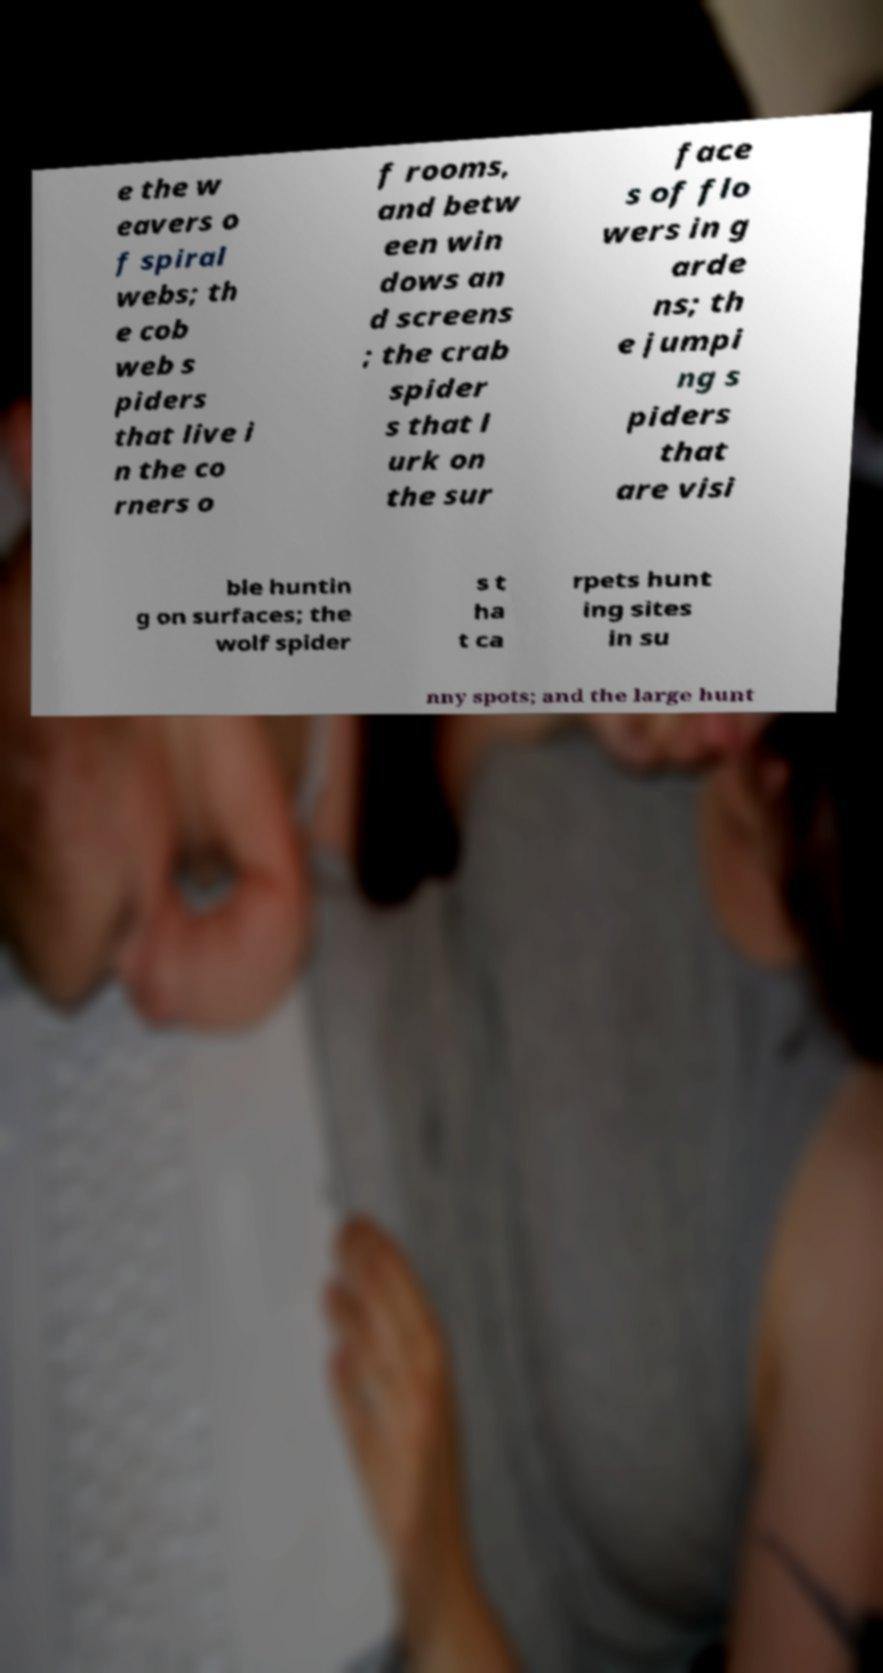There's text embedded in this image that I need extracted. Can you transcribe it verbatim? e the w eavers o f spiral webs; th e cob web s piders that live i n the co rners o f rooms, and betw een win dows an d screens ; the crab spider s that l urk on the sur face s of flo wers in g arde ns; th e jumpi ng s piders that are visi ble huntin g on surfaces; the wolf spider s t ha t ca rpets hunt ing sites in su nny spots; and the large hunt 